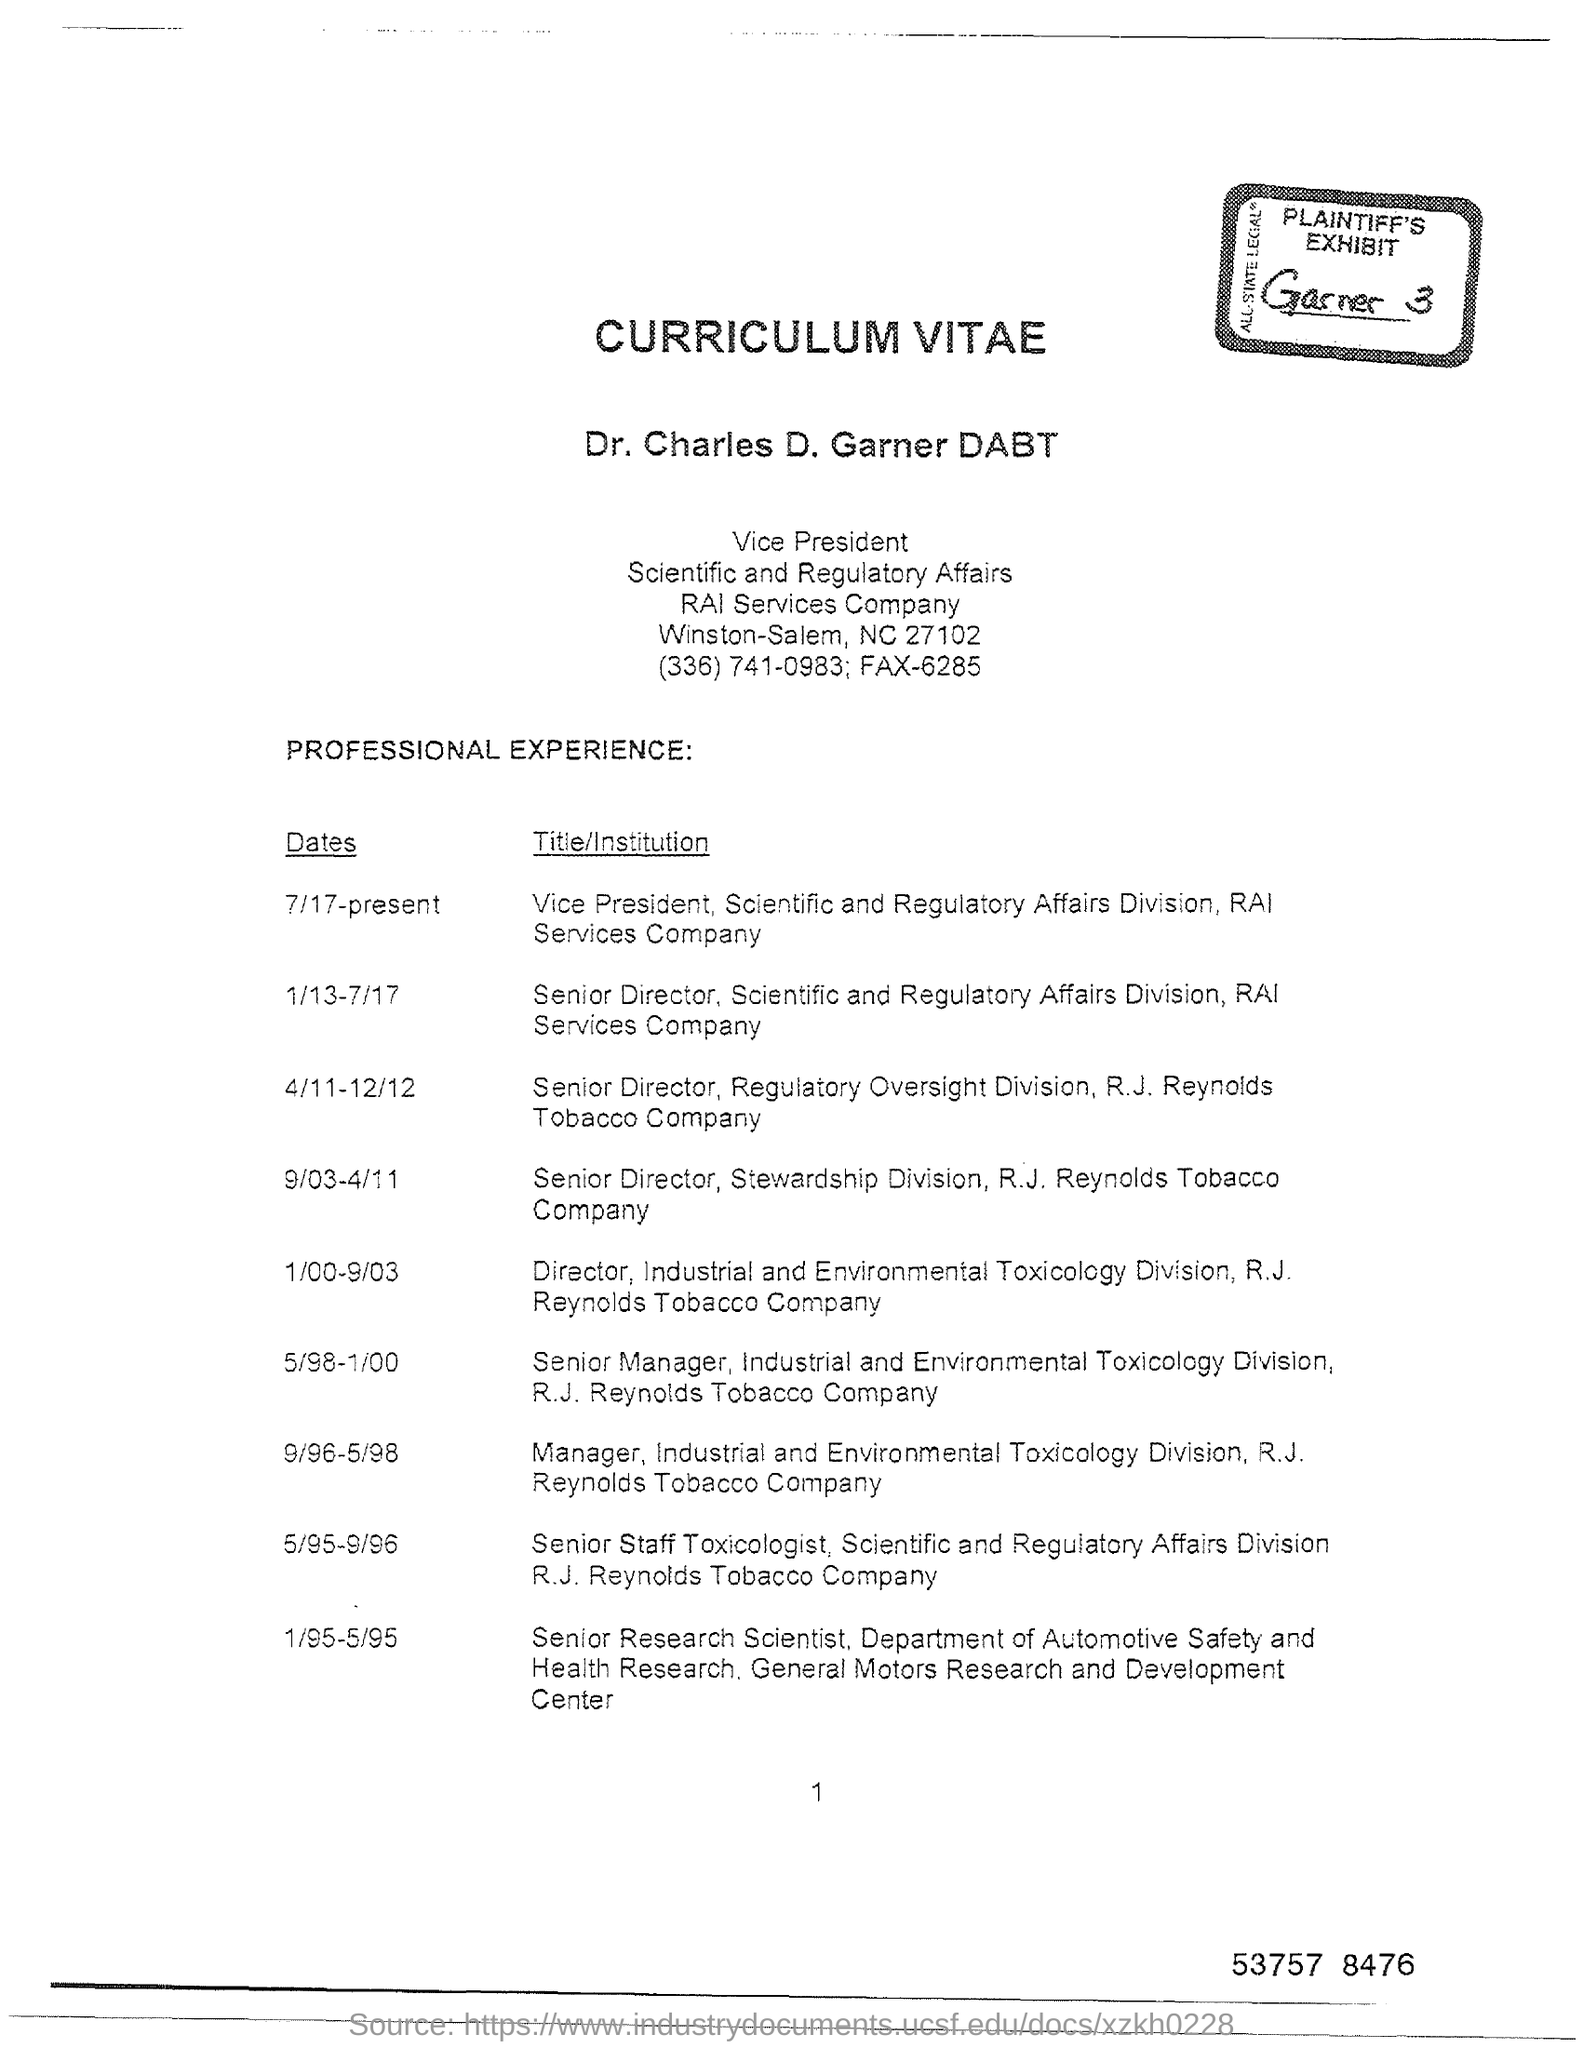Whose Curriculum Vitae is this?
Make the answer very short. Dr. Charles D. Garner DABT. Which company is Dr. Charles D. Garner DABT a vice president of?
Make the answer very short. RAI Services Company. 